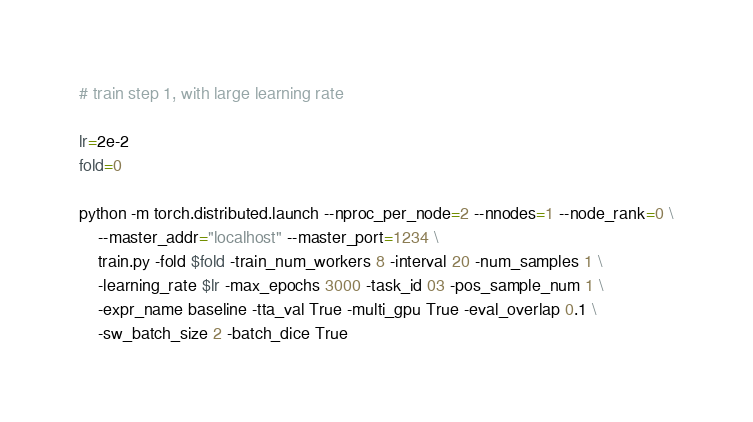<code> <loc_0><loc_0><loc_500><loc_500><_Bash_># train step 1, with large learning rate

lr=2e-2
fold=0

python -m torch.distributed.launch --nproc_per_node=2 --nnodes=1 --node_rank=0 \
    --master_addr="localhost" --master_port=1234 \
	train.py -fold $fold -train_num_workers 8 -interval 20 -num_samples 1 \
	-learning_rate $lr -max_epochs 3000 -task_id 03 -pos_sample_num 1 \
	-expr_name baseline -tta_val True -multi_gpu True -eval_overlap 0.1 \
	-sw_batch_size 2 -batch_dice True
</code> 